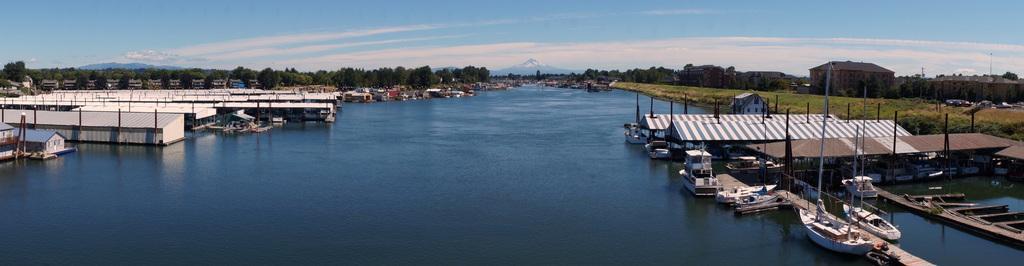In one or two sentences, can you explain what this image depicts? In this image I can see the water, few boats on the surface of the water, few sheds and few buildings. In the background I can see few trees which are green in color, few mountains and the sky. 